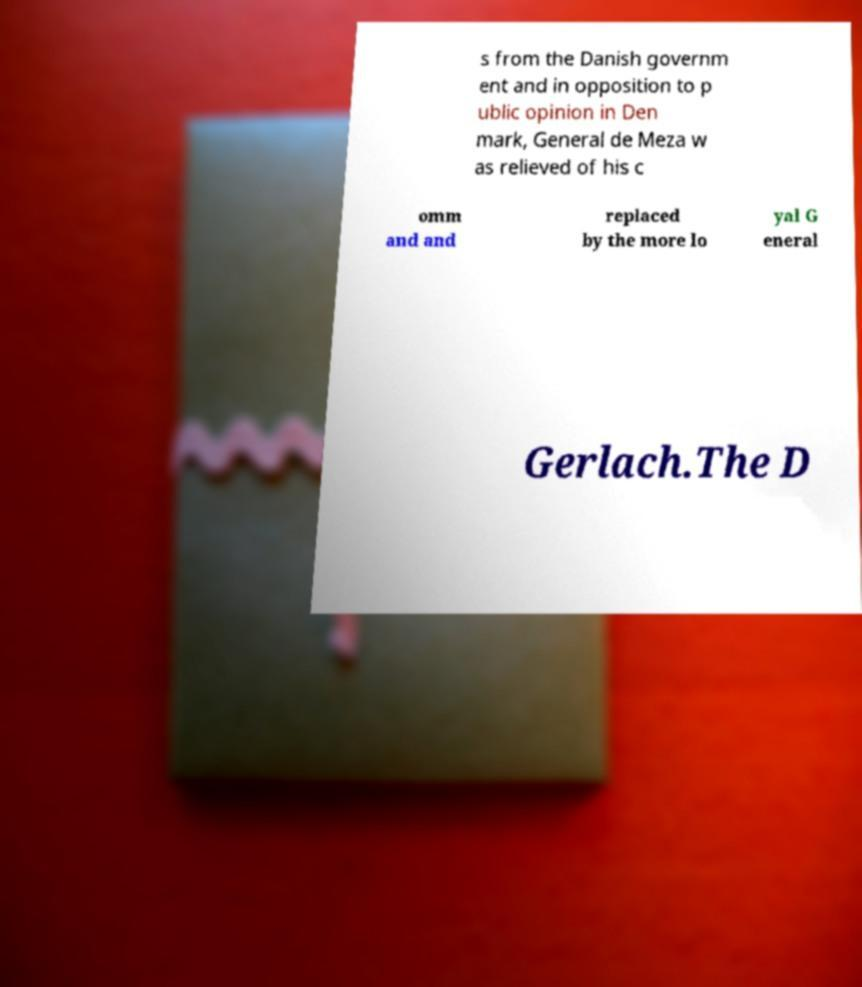Can you accurately transcribe the text from the provided image for me? s from the Danish governm ent and in opposition to p ublic opinion in Den mark, General de Meza w as relieved of his c omm and and replaced by the more lo yal G eneral Gerlach.The D 